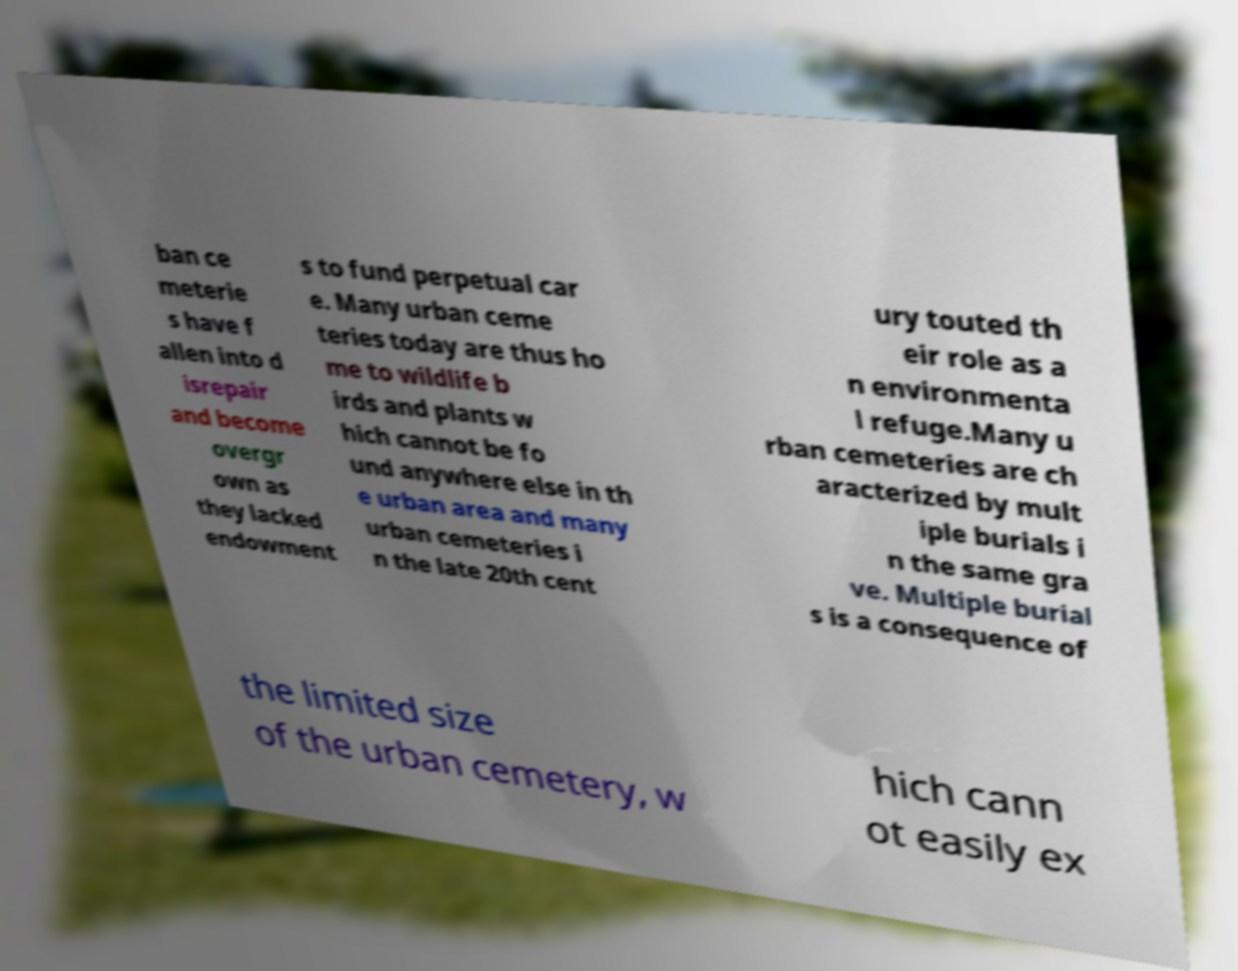For documentation purposes, I need the text within this image transcribed. Could you provide that? ban ce meterie s have f allen into d isrepair and become overgr own as they lacked endowment s to fund perpetual car e. Many urban ceme teries today are thus ho me to wildlife b irds and plants w hich cannot be fo und anywhere else in th e urban area and many urban cemeteries i n the late 20th cent ury touted th eir role as a n environmenta l refuge.Many u rban cemeteries are ch aracterized by mult iple burials i n the same gra ve. Multiple burial s is a consequence of the limited size of the urban cemetery, w hich cann ot easily ex 